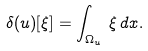Convert formula to latex. <formula><loc_0><loc_0><loc_500><loc_500>\delta ( u ) [ \xi ] = \int _ { \Omega _ { u } } \, \xi \, d x .</formula> 